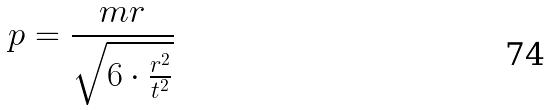Convert formula to latex. <formula><loc_0><loc_0><loc_500><loc_500>p = \frac { m r } { \sqrt { 6 \cdot \frac { r ^ { 2 } } { t ^ { 2 } } } }</formula> 